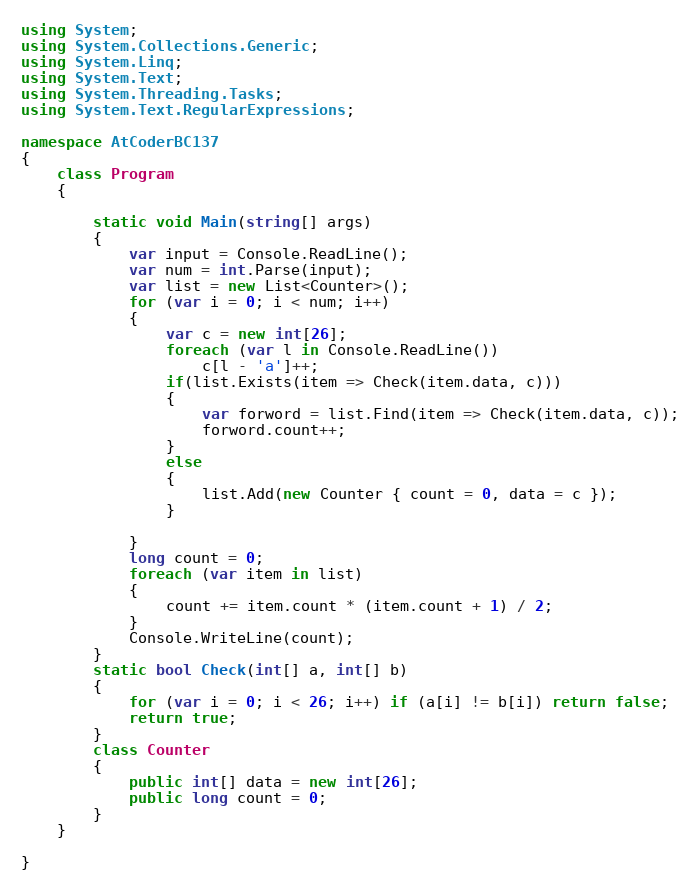<code> <loc_0><loc_0><loc_500><loc_500><_C#_>using System;
using System.Collections.Generic;
using System.Linq;
using System.Text;
using System.Threading.Tasks;
using System.Text.RegularExpressions;

namespace AtCoderBC137
{
    class Program
    {

        static void Main(string[] args)
        {
            var input = Console.ReadLine();
            var num = int.Parse(input);
            var list = new List<Counter>();
            for (var i = 0; i < num; i++)
            {
                var c = new int[26];
                foreach (var l in Console.ReadLine())
                    c[l - 'a']++;
                if(list.Exists(item => Check(item.data, c)))
                {
                    var forword = list.Find(item => Check(item.data, c));
                    forword.count++;
                }
                else
                {
                    list.Add(new Counter { count = 0, data = c });
                }

            }
            long count = 0;
            foreach (var item in list)
            {
                count += item.count * (item.count + 1) / 2;
            }
            Console.WriteLine(count);
        }
        static bool Check(int[] a, int[] b)
        {
            for (var i = 0; i < 26; i++) if (a[i] != b[i]) return false;
            return true;
        }
        class Counter
        {
            public int[] data = new int[26];
            public long count = 0;
        }
    }

}
</code> 